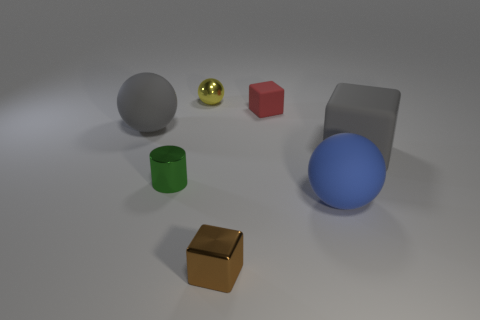What number of other objects are there of the same color as the small metallic sphere?
Offer a terse response. 0. There is a green object that is left of the small matte block; is its size the same as the brown metallic thing in front of the metallic ball?
Make the answer very short. Yes. There is a cube that is in front of the large matte object that is in front of the large block; what is its size?
Your answer should be compact. Small. There is a tiny object that is behind the tiny green metal thing and to the right of the tiny yellow shiny thing; what material is it?
Your answer should be very brief. Rubber. What is the color of the small metal block?
Provide a short and direct response. Brown. The big rubber object that is in front of the green metallic thing has what shape?
Make the answer very short. Sphere. Are there any tiny green metallic cylinders behind the matte ball behind the big gray thing that is to the right of the blue rubber object?
Offer a terse response. No. Is there any other thing that is the same shape as the green metallic thing?
Keep it short and to the point. No. Are there any tiny blue metal cubes?
Your response must be concise. No. Is the material of the large sphere on the left side of the tiny green metal cylinder the same as the yellow thing that is behind the tiny green cylinder?
Make the answer very short. No. 